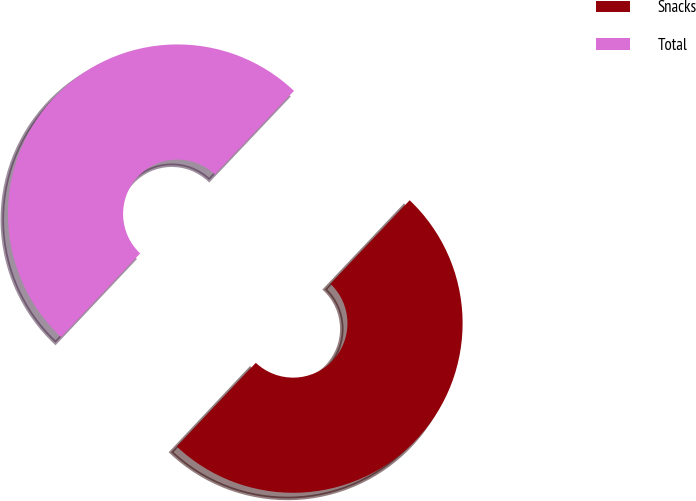<chart> <loc_0><loc_0><loc_500><loc_500><pie_chart><fcel>Snacks<fcel>Total<nl><fcel>49.97%<fcel>50.03%<nl></chart> 